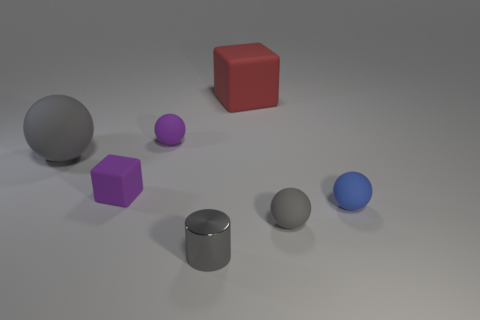Subtract 1 spheres. How many spheres are left? 3 Add 2 big matte balls. How many objects exist? 9 Subtract all balls. How many objects are left? 3 Add 4 large red cubes. How many large red cubes exist? 5 Subtract 0 yellow cubes. How many objects are left? 7 Subtract all big gray rubber things. Subtract all tiny purple shiny cylinders. How many objects are left? 6 Add 7 tiny purple matte objects. How many tiny purple matte objects are left? 9 